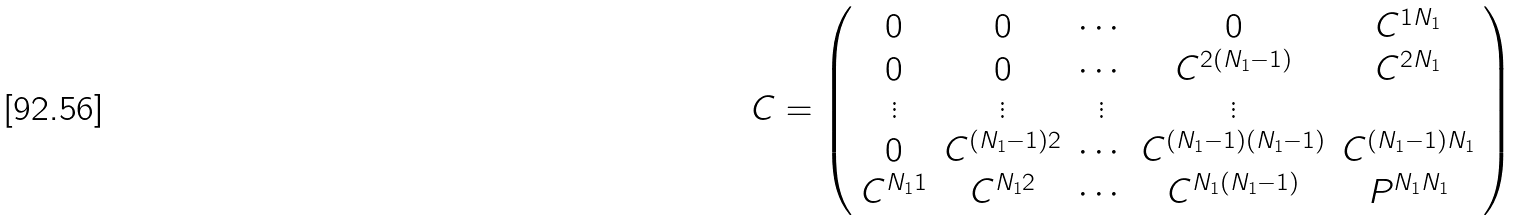<formula> <loc_0><loc_0><loc_500><loc_500>C = \left ( \begin{array} { c c c c c } 0 & 0 & \cdots & 0 & C ^ { 1 N _ { 1 } } \\ 0 & 0 & \cdots & C ^ { 2 ( N _ { 1 } - 1 ) } & C ^ { 2 N _ { 1 } } \\ \vdots & \vdots & \vdots & \vdots \\ 0 & C ^ { ( N _ { 1 } - 1 ) 2 } & \cdots & C ^ { ( N _ { 1 } - 1 ) ( N _ { 1 } - 1 ) } & C ^ { ( N _ { 1 } - 1 ) N _ { 1 } } \\ C ^ { N _ { 1 } 1 } & C ^ { N _ { 1 } 2 } & \cdots & C ^ { N _ { 1 } ( N _ { 1 } - 1 ) } & P ^ { N _ { 1 } N _ { 1 } } \end{array} \right )</formula> 